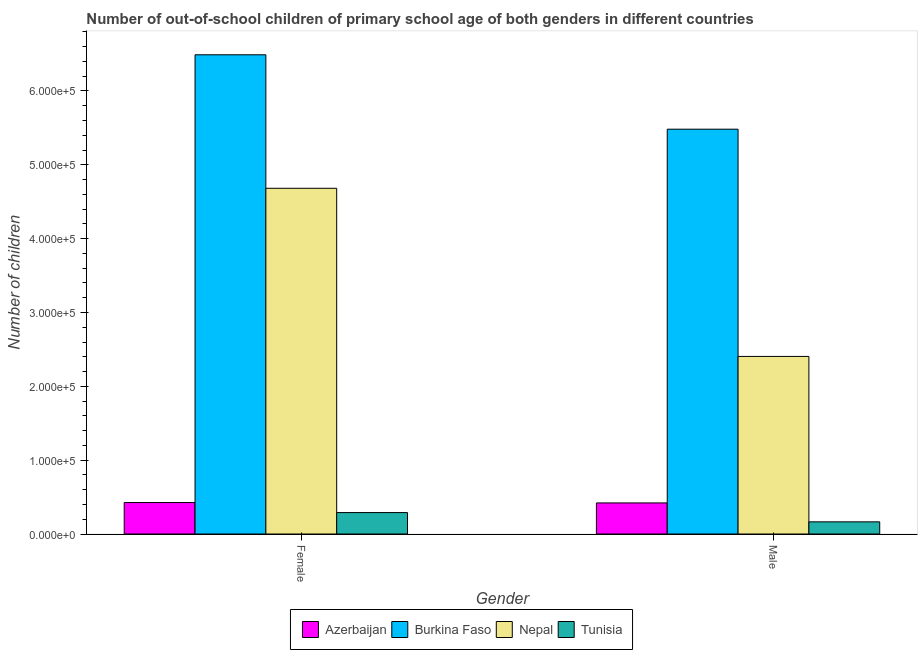How many different coloured bars are there?
Your response must be concise. 4. Are the number of bars on each tick of the X-axis equal?
Give a very brief answer. Yes. How many bars are there on the 2nd tick from the right?
Offer a terse response. 4. What is the label of the 1st group of bars from the left?
Give a very brief answer. Female. What is the number of female out-of-school students in Tunisia?
Provide a succinct answer. 2.90e+04. Across all countries, what is the maximum number of female out-of-school students?
Make the answer very short. 6.49e+05. Across all countries, what is the minimum number of male out-of-school students?
Your answer should be compact. 1.64e+04. In which country was the number of female out-of-school students maximum?
Ensure brevity in your answer.  Burkina Faso. In which country was the number of female out-of-school students minimum?
Your response must be concise. Tunisia. What is the total number of male out-of-school students in the graph?
Your answer should be very brief. 8.47e+05. What is the difference between the number of female out-of-school students in Burkina Faso and that in Azerbaijan?
Make the answer very short. 6.06e+05. What is the difference between the number of female out-of-school students in Tunisia and the number of male out-of-school students in Azerbaijan?
Make the answer very short. -1.31e+04. What is the average number of female out-of-school students per country?
Your response must be concise. 2.97e+05. What is the difference between the number of male out-of-school students and number of female out-of-school students in Tunisia?
Your answer should be compact. -1.26e+04. In how many countries, is the number of female out-of-school students greater than 460000 ?
Offer a very short reply. 2. What is the ratio of the number of female out-of-school students in Azerbaijan to that in Burkina Faso?
Give a very brief answer. 0.07. What does the 4th bar from the left in Male represents?
Your answer should be very brief. Tunisia. What does the 2nd bar from the right in Female represents?
Your answer should be compact. Nepal. Are all the bars in the graph horizontal?
Offer a terse response. No. Does the graph contain any zero values?
Keep it short and to the point. No. Does the graph contain grids?
Provide a short and direct response. No. How many legend labels are there?
Ensure brevity in your answer.  4. How are the legend labels stacked?
Give a very brief answer. Horizontal. What is the title of the graph?
Keep it short and to the point. Number of out-of-school children of primary school age of both genders in different countries. What is the label or title of the X-axis?
Keep it short and to the point. Gender. What is the label or title of the Y-axis?
Your response must be concise. Number of children. What is the Number of children of Azerbaijan in Female?
Provide a short and direct response. 4.26e+04. What is the Number of children of Burkina Faso in Female?
Make the answer very short. 6.49e+05. What is the Number of children of Nepal in Female?
Ensure brevity in your answer.  4.68e+05. What is the Number of children in Tunisia in Female?
Your answer should be very brief. 2.90e+04. What is the Number of children of Azerbaijan in Male?
Offer a terse response. 4.21e+04. What is the Number of children in Burkina Faso in Male?
Your answer should be compact. 5.48e+05. What is the Number of children of Nepal in Male?
Give a very brief answer. 2.40e+05. What is the Number of children in Tunisia in Male?
Your response must be concise. 1.64e+04. Across all Gender, what is the maximum Number of children of Azerbaijan?
Make the answer very short. 4.26e+04. Across all Gender, what is the maximum Number of children of Burkina Faso?
Your answer should be compact. 6.49e+05. Across all Gender, what is the maximum Number of children of Nepal?
Provide a succinct answer. 4.68e+05. Across all Gender, what is the maximum Number of children in Tunisia?
Make the answer very short. 2.90e+04. Across all Gender, what is the minimum Number of children in Azerbaijan?
Offer a very short reply. 4.21e+04. Across all Gender, what is the minimum Number of children of Burkina Faso?
Your response must be concise. 5.48e+05. Across all Gender, what is the minimum Number of children in Nepal?
Provide a succinct answer. 2.40e+05. Across all Gender, what is the minimum Number of children of Tunisia?
Offer a very short reply. 1.64e+04. What is the total Number of children in Azerbaijan in the graph?
Keep it short and to the point. 8.47e+04. What is the total Number of children in Burkina Faso in the graph?
Ensure brevity in your answer.  1.20e+06. What is the total Number of children of Nepal in the graph?
Keep it short and to the point. 7.09e+05. What is the total Number of children in Tunisia in the graph?
Keep it short and to the point. 4.55e+04. What is the difference between the Number of children in Azerbaijan in Female and that in Male?
Provide a short and direct response. 536. What is the difference between the Number of children in Burkina Faso in Female and that in Male?
Keep it short and to the point. 1.01e+05. What is the difference between the Number of children in Nepal in Female and that in Male?
Keep it short and to the point. 2.28e+05. What is the difference between the Number of children in Tunisia in Female and that in Male?
Provide a short and direct response. 1.26e+04. What is the difference between the Number of children in Azerbaijan in Female and the Number of children in Burkina Faso in Male?
Your answer should be very brief. -5.06e+05. What is the difference between the Number of children in Azerbaijan in Female and the Number of children in Nepal in Male?
Keep it short and to the point. -1.98e+05. What is the difference between the Number of children in Azerbaijan in Female and the Number of children in Tunisia in Male?
Offer a terse response. 2.62e+04. What is the difference between the Number of children of Burkina Faso in Female and the Number of children of Nepal in Male?
Make the answer very short. 4.09e+05. What is the difference between the Number of children in Burkina Faso in Female and the Number of children in Tunisia in Male?
Provide a succinct answer. 6.33e+05. What is the difference between the Number of children in Nepal in Female and the Number of children in Tunisia in Male?
Ensure brevity in your answer.  4.52e+05. What is the average Number of children in Azerbaijan per Gender?
Make the answer very short. 4.24e+04. What is the average Number of children in Burkina Faso per Gender?
Your answer should be compact. 5.99e+05. What is the average Number of children of Nepal per Gender?
Your response must be concise. 3.54e+05. What is the average Number of children of Tunisia per Gender?
Your answer should be very brief. 2.27e+04. What is the difference between the Number of children of Azerbaijan and Number of children of Burkina Faso in Female?
Make the answer very short. -6.06e+05. What is the difference between the Number of children of Azerbaijan and Number of children of Nepal in Female?
Keep it short and to the point. -4.26e+05. What is the difference between the Number of children of Azerbaijan and Number of children of Tunisia in Female?
Offer a terse response. 1.36e+04. What is the difference between the Number of children in Burkina Faso and Number of children in Nepal in Female?
Offer a terse response. 1.81e+05. What is the difference between the Number of children of Burkina Faso and Number of children of Tunisia in Female?
Provide a short and direct response. 6.20e+05. What is the difference between the Number of children of Nepal and Number of children of Tunisia in Female?
Your answer should be compact. 4.39e+05. What is the difference between the Number of children in Azerbaijan and Number of children in Burkina Faso in Male?
Offer a very short reply. -5.06e+05. What is the difference between the Number of children in Azerbaijan and Number of children in Nepal in Male?
Make the answer very short. -1.98e+05. What is the difference between the Number of children of Azerbaijan and Number of children of Tunisia in Male?
Offer a terse response. 2.56e+04. What is the difference between the Number of children in Burkina Faso and Number of children in Nepal in Male?
Your answer should be very brief. 3.08e+05. What is the difference between the Number of children of Burkina Faso and Number of children of Tunisia in Male?
Your answer should be very brief. 5.32e+05. What is the difference between the Number of children of Nepal and Number of children of Tunisia in Male?
Your answer should be compact. 2.24e+05. What is the ratio of the Number of children in Azerbaijan in Female to that in Male?
Keep it short and to the point. 1.01. What is the ratio of the Number of children in Burkina Faso in Female to that in Male?
Give a very brief answer. 1.18. What is the ratio of the Number of children in Nepal in Female to that in Male?
Make the answer very short. 1.95. What is the ratio of the Number of children of Tunisia in Female to that in Male?
Your answer should be very brief. 1.76. What is the difference between the highest and the second highest Number of children in Azerbaijan?
Make the answer very short. 536. What is the difference between the highest and the second highest Number of children of Burkina Faso?
Offer a very short reply. 1.01e+05. What is the difference between the highest and the second highest Number of children of Nepal?
Your response must be concise. 2.28e+05. What is the difference between the highest and the second highest Number of children of Tunisia?
Your answer should be very brief. 1.26e+04. What is the difference between the highest and the lowest Number of children in Azerbaijan?
Give a very brief answer. 536. What is the difference between the highest and the lowest Number of children in Burkina Faso?
Your answer should be very brief. 1.01e+05. What is the difference between the highest and the lowest Number of children in Nepal?
Provide a succinct answer. 2.28e+05. What is the difference between the highest and the lowest Number of children of Tunisia?
Offer a very short reply. 1.26e+04. 